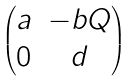Convert formula to latex. <formula><loc_0><loc_0><loc_500><loc_500>\begin{pmatrix} a & - b Q \\ 0 & d \end{pmatrix}</formula> 